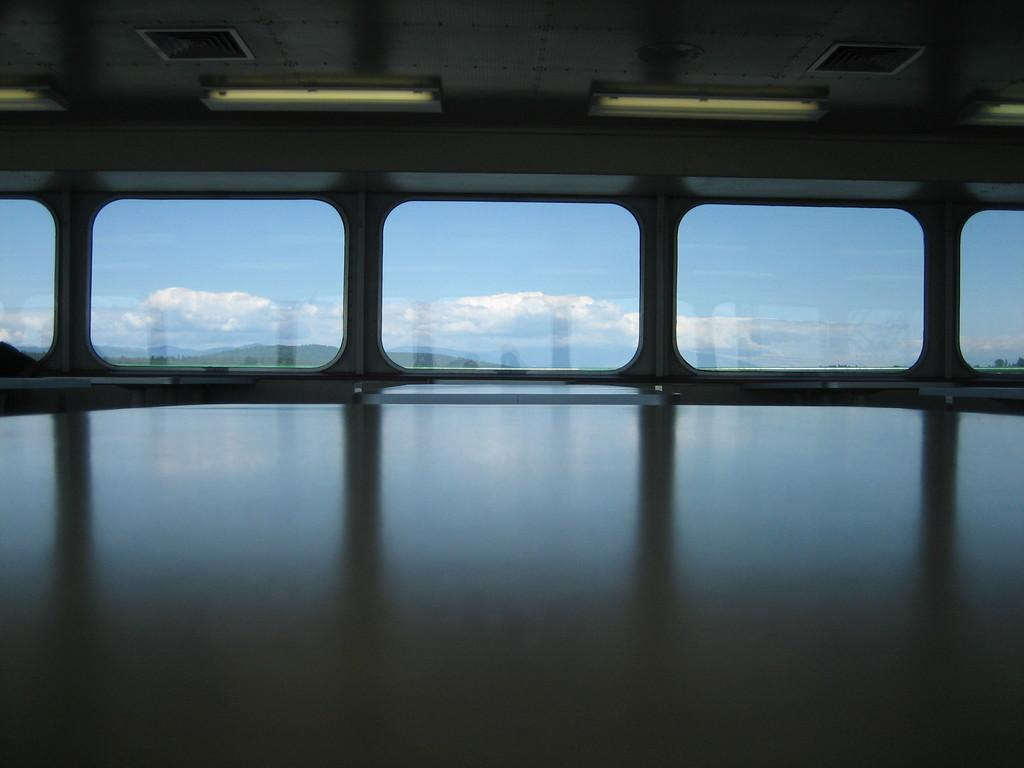What type of furniture can be seen in the image? There are tables in the image. What is present on the ceiling in the image? There is a ceiling with lights in the image. What material is present in the background of the image? There is glass in the background of the image. What can be seen through the glass in the image? The sky and clouds are visible through the glass. How many nails are visible on the tables in the image? There is no mention of nails in the image, so we cannot determine how many are visible. What type of tomatoes can be seen growing through the glass in the image? There are no tomatoes present in the image; only the sky and clouds are visible through the glass. 